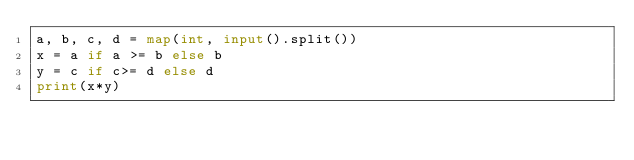Convert code to text. <code><loc_0><loc_0><loc_500><loc_500><_Python_>a, b, c, d = map(int, input().split())
x = a if a >= b else b
y = c if c>= d else d
print(x*y)</code> 